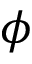<formula> <loc_0><loc_0><loc_500><loc_500>\phi</formula> 